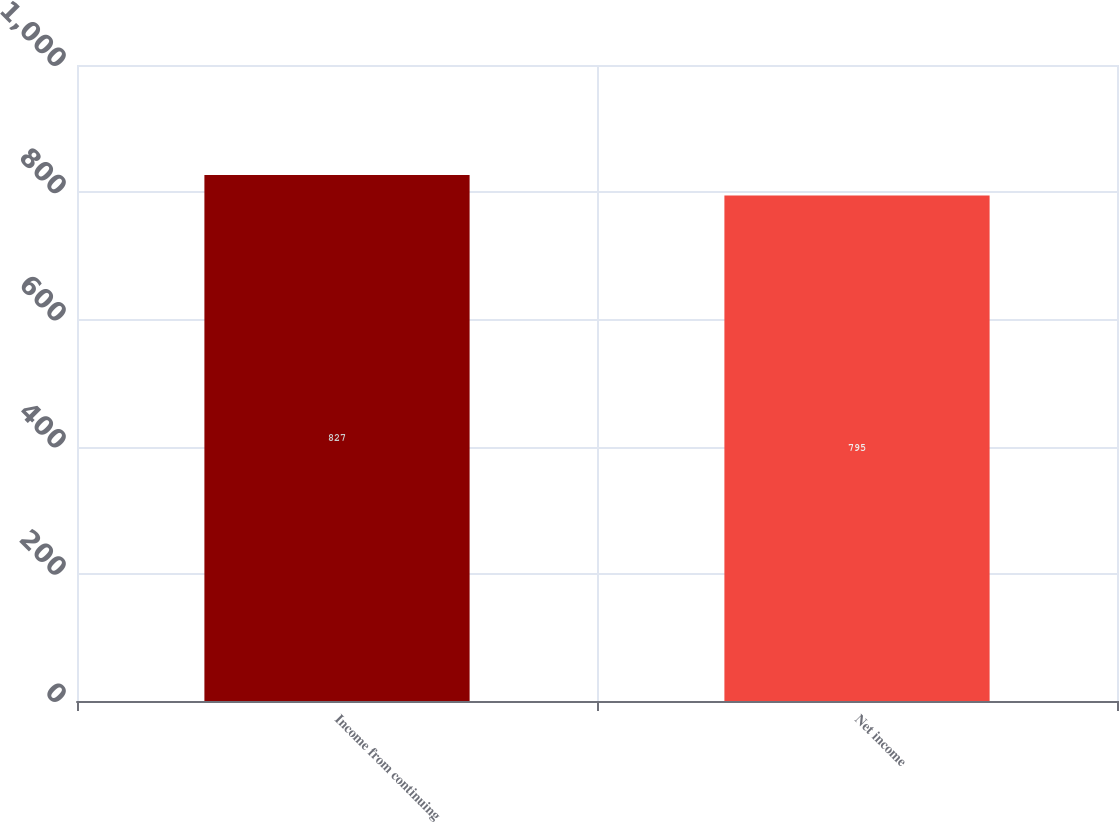<chart> <loc_0><loc_0><loc_500><loc_500><bar_chart><fcel>Income from continuing<fcel>Net income<nl><fcel>827<fcel>795<nl></chart> 